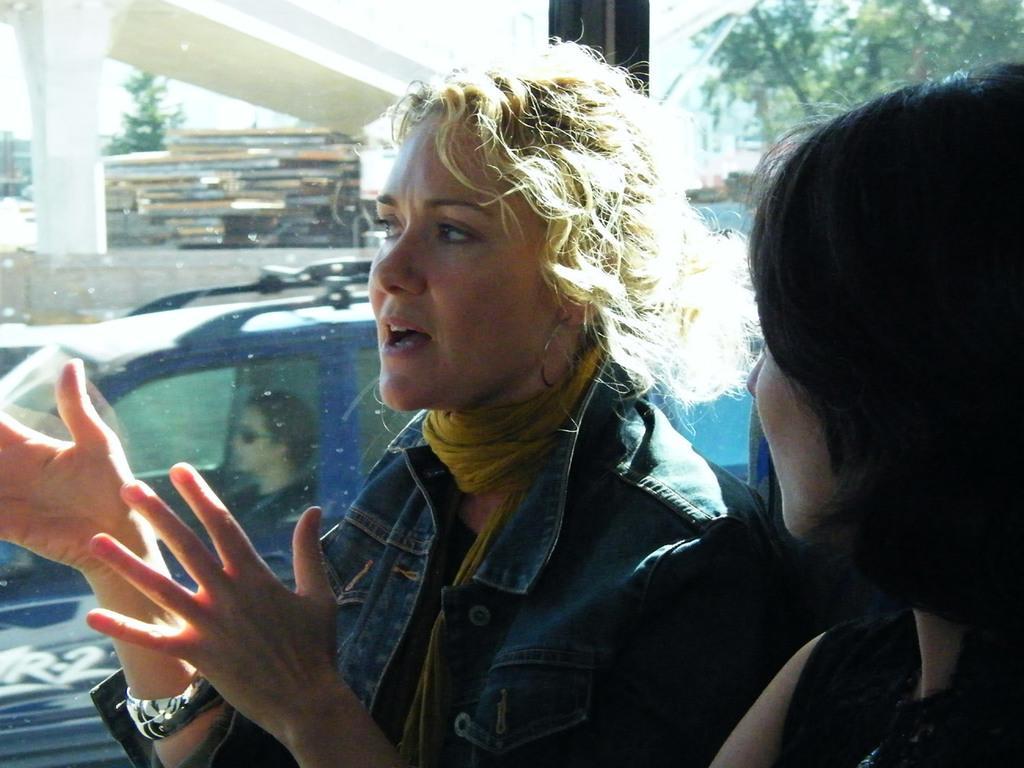In one or two sentences, can you explain what this image depicts? In this image we can see a two women sitting on a chair under the bus. From the window we can see a woman who is driving a blue color car. On the top left corner we can see a bridge. On the top right corner we can see a tree. 